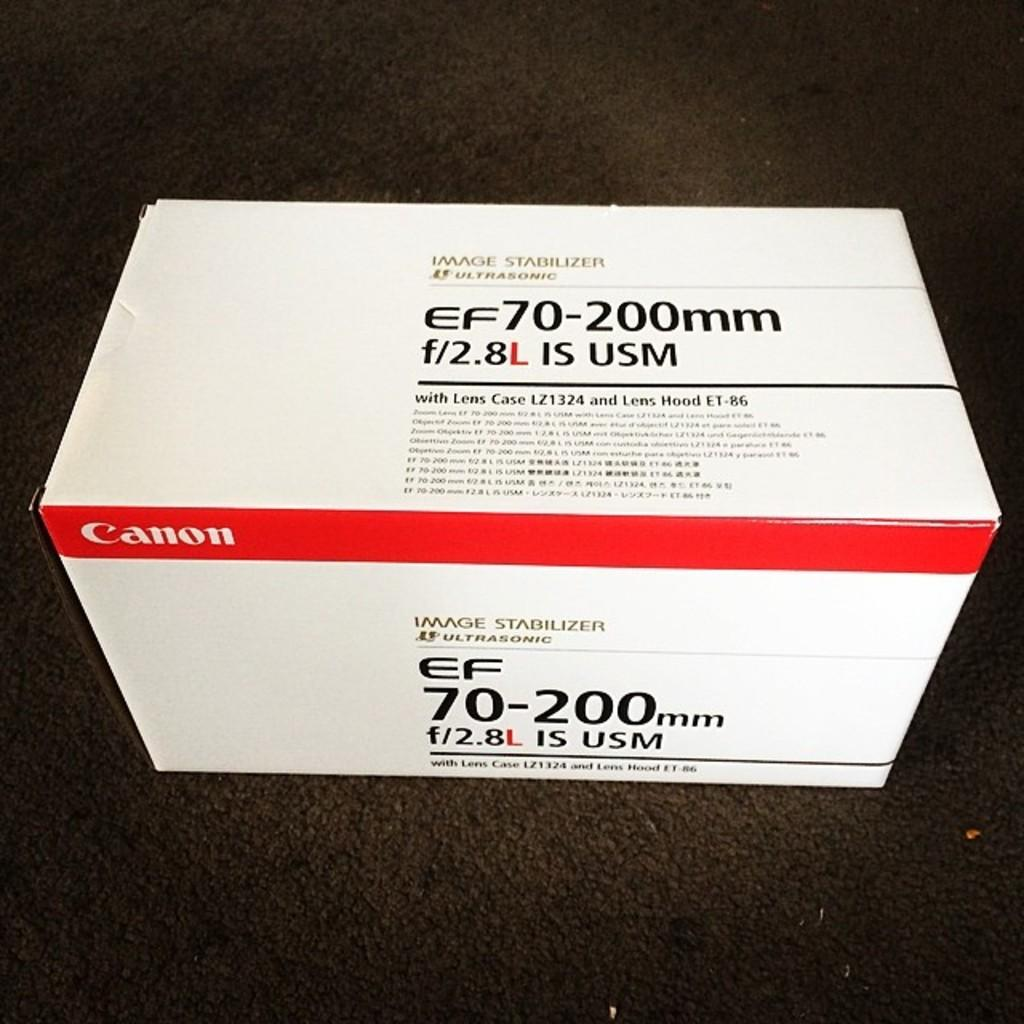<image>
Provide a brief description of the given image. a white sign with the word Canon on it 